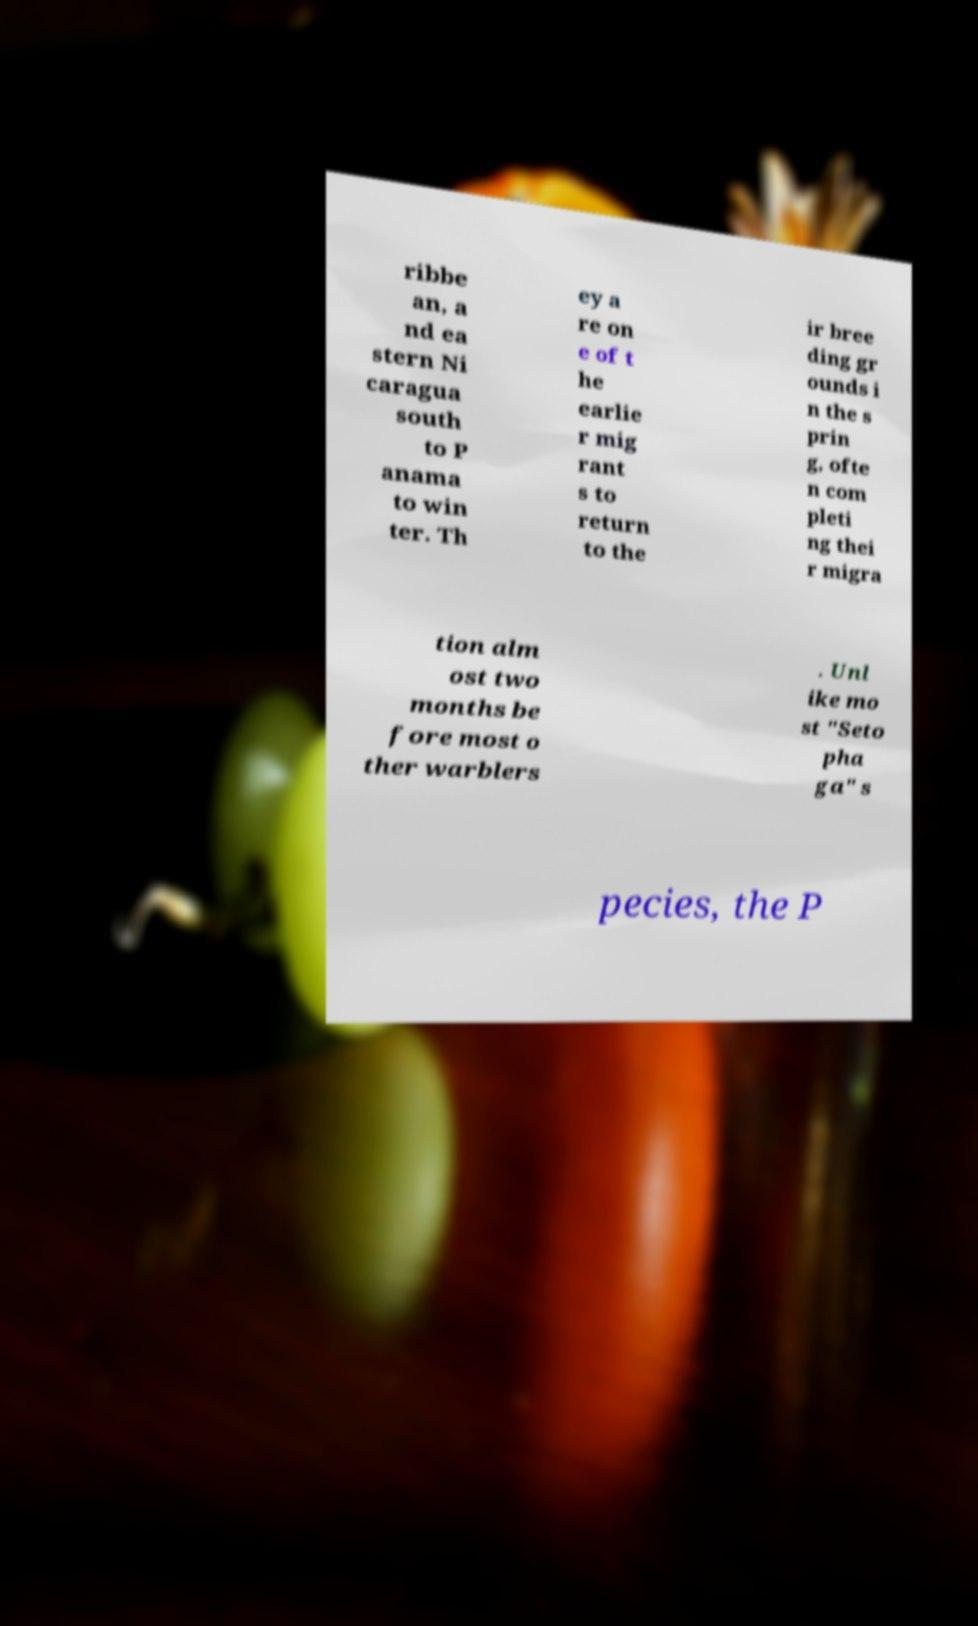There's text embedded in this image that I need extracted. Can you transcribe it verbatim? ribbe an, a nd ea stern Ni caragua south to P anama to win ter. Th ey a re on e of t he earlie r mig rant s to return to the ir bree ding gr ounds i n the s prin g, ofte n com pleti ng thei r migra tion alm ost two months be fore most o ther warblers . Unl ike mo st "Seto pha ga" s pecies, the P 